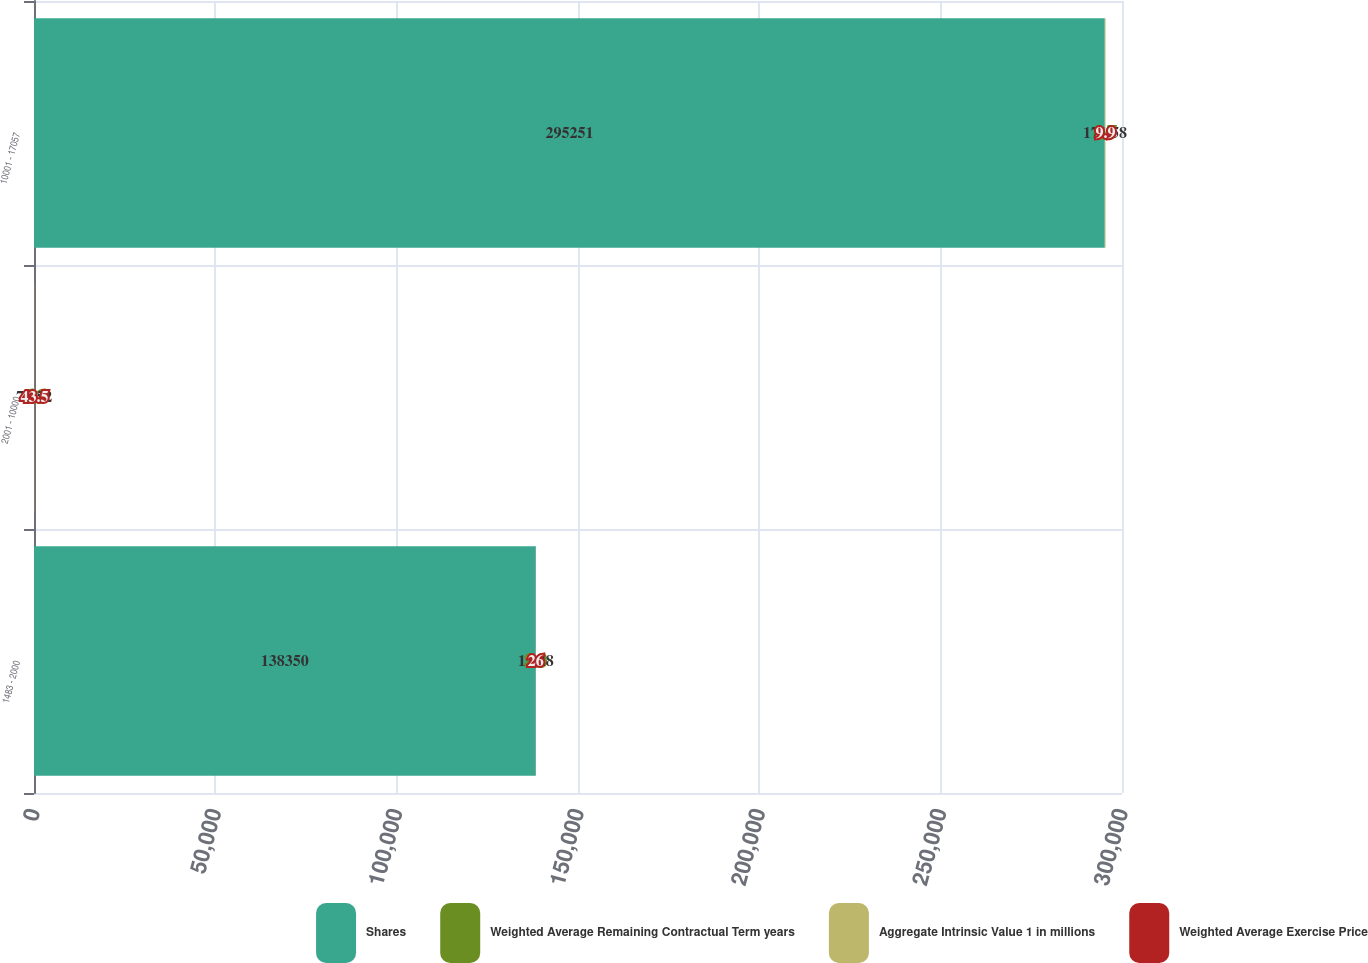<chart> <loc_0><loc_0><loc_500><loc_500><stacked_bar_chart><ecel><fcel>1483 - 2000<fcel>2001 - 10000<fcel>10001 - 17057<nl><fcel>Shares<fcel>138350<fcel>26<fcel>295251<nl><fcel>Weighted Average Remaining Contractual Term years<fcel>3.3<fcel>6.6<fcel>8.5<nl><fcel>Aggregate Intrinsic Value 1 in millions<fcel>15.28<fcel>72.52<fcel>171.58<nl><fcel>Weighted Average Exercise Price<fcel>26<fcel>43.5<fcel>9.9<nl></chart> 